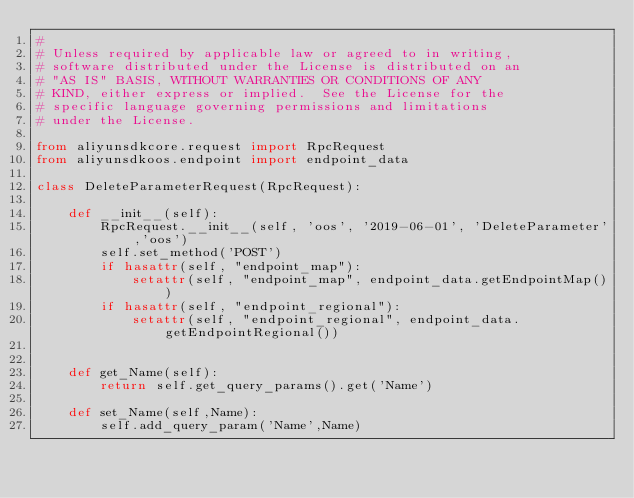<code> <loc_0><loc_0><loc_500><loc_500><_Python_>#
# Unless required by applicable law or agreed to in writing,
# software distributed under the License is distributed on an
# "AS IS" BASIS, WITHOUT WARRANTIES OR CONDITIONS OF ANY
# KIND, either express or implied.  See the License for the
# specific language governing permissions and limitations
# under the License.

from aliyunsdkcore.request import RpcRequest
from aliyunsdkoos.endpoint import endpoint_data

class DeleteParameterRequest(RpcRequest):

	def __init__(self):
		RpcRequest.__init__(self, 'oos', '2019-06-01', 'DeleteParameter','oos')
		self.set_method('POST')
		if hasattr(self, "endpoint_map"):
			setattr(self, "endpoint_map", endpoint_data.getEndpointMap())
		if hasattr(self, "endpoint_regional"):
			setattr(self, "endpoint_regional", endpoint_data.getEndpointRegional())


	def get_Name(self):
		return self.get_query_params().get('Name')

	def set_Name(self,Name):
		self.add_query_param('Name',Name)</code> 